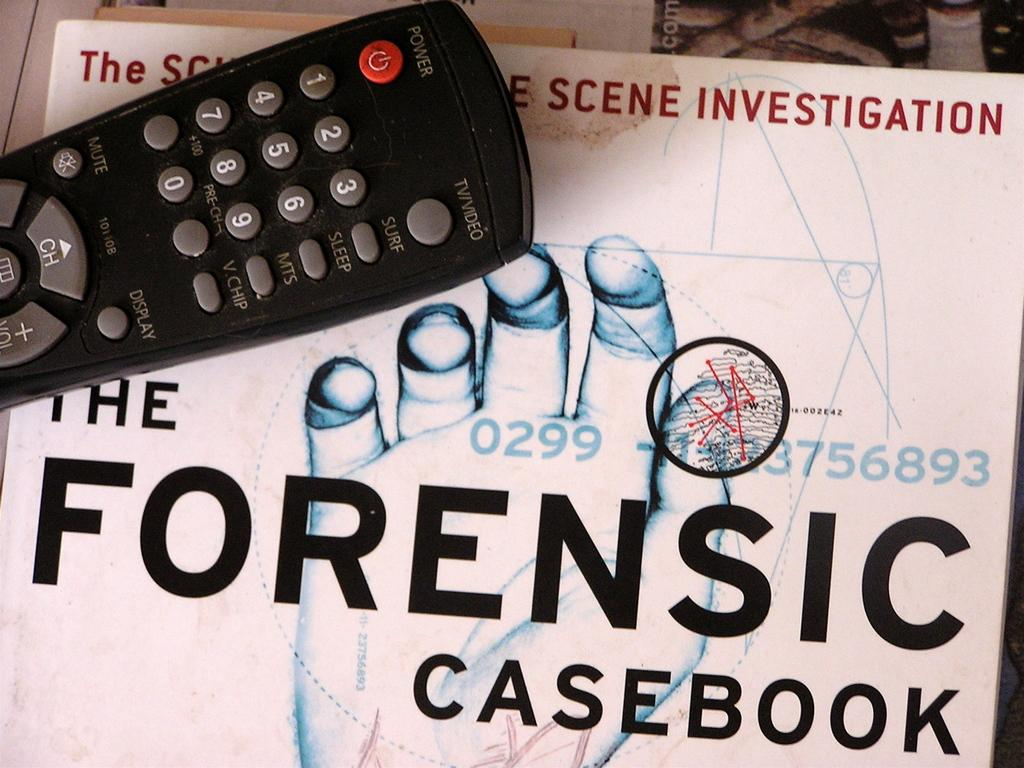<image>
Offer a succinct explanation of the picture presented. Remote control sitting on top of title that state the Forensic Casebook. 